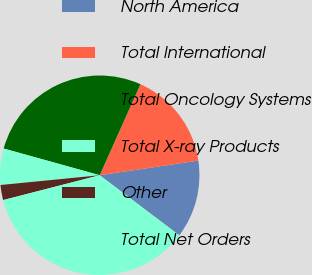Convert chart. <chart><loc_0><loc_0><loc_500><loc_500><pie_chart><fcel>North America<fcel>Total International<fcel>Total Oncology Systems<fcel>Total X-ray Products<fcel>Other<fcel>Total Net Orders<nl><fcel>12.64%<fcel>15.96%<fcel>27.38%<fcel>5.88%<fcel>2.45%<fcel>35.7%<nl></chart> 